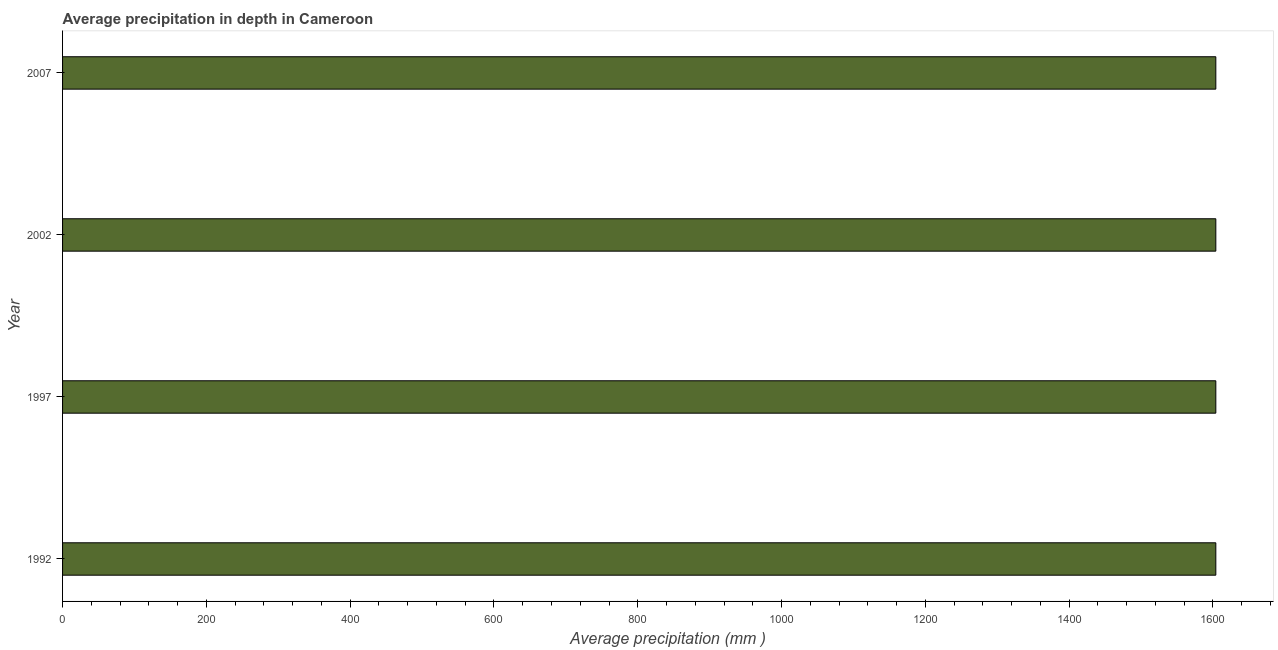Does the graph contain grids?
Your response must be concise. No. What is the title of the graph?
Ensure brevity in your answer.  Average precipitation in depth in Cameroon. What is the label or title of the X-axis?
Provide a short and direct response. Average precipitation (mm ). What is the label or title of the Y-axis?
Your answer should be compact. Year. What is the average precipitation in depth in 2007?
Your answer should be very brief. 1604. Across all years, what is the maximum average precipitation in depth?
Make the answer very short. 1604. Across all years, what is the minimum average precipitation in depth?
Your answer should be compact. 1604. In which year was the average precipitation in depth minimum?
Keep it short and to the point. 1992. What is the sum of the average precipitation in depth?
Your response must be concise. 6416. What is the difference between the average precipitation in depth in 1992 and 2002?
Your answer should be compact. 0. What is the average average precipitation in depth per year?
Provide a succinct answer. 1604. What is the median average precipitation in depth?
Give a very brief answer. 1604. In how many years, is the average precipitation in depth greater than 240 mm?
Your answer should be very brief. 4. Do a majority of the years between 2002 and 1997 (inclusive) have average precipitation in depth greater than 200 mm?
Offer a very short reply. No. What is the ratio of the average precipitation in depth in 1997 to that in 2007?
Your answer should be compact. 1. What is the difference between the highest and the second highest average precipitation in depth?
Give a very brief answer. 0. What is the difference between the highest and the lowest average precipitation in depth?
Offer a terse response. 0. What is the difference between two consecutive major ticks on the X-axis?
Your response must be concise. 200. What is the Average precipitation (mm ) of 1992?
Provide a short and direct response. 1604. What is the Average precipitation (mm ) of 1997?
Provide a succinct answer. 1604. What is the Average precipitation (mm ) of 2002?
Offer a very short reply. 1604. What is the Average precipitation (mm ) in 2007?
Keep it short and to the point. 1604. What is the difference between the Average precipitation (mm ) in 1992 and 1997?
Provide a short and direct response. 0. What is the difference between the Average precipitation (mm ) in 1992 and 2002?
Ensure brevity in your answer.  0. What is the difference between the Average precipitation (mm ) in 1997 and 2007?
Ensure brevity in your answer.  0. What is the difference between the Average precipitation (mm ) in 2002 and 2007?
Keep it short and to the point. 0. What is the ratio of the Average precipitation (mm ) in 1992 to that in 1997?
Provide a short and direct response. 1. What is the ratio of the Average precipitation (mm ) in 1997 to that in 2007?
Offer a terse response. 1. What is the ratio of the Average precipitation (mm ) in 2002 to that in 2007?
Provide a succinct answer. 1. 